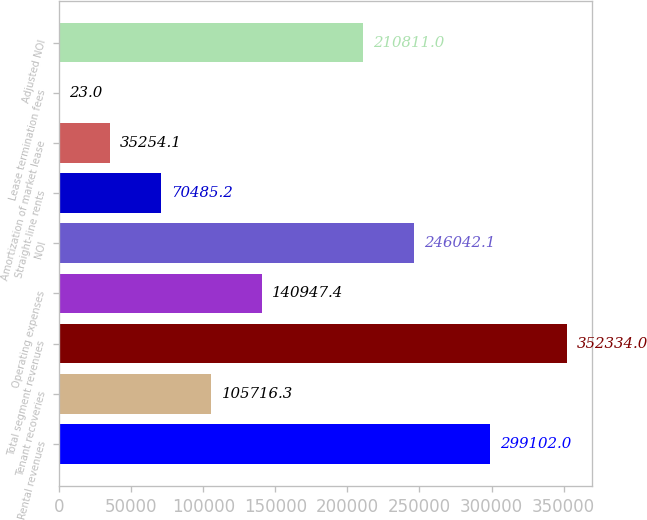Convert chart. <chart><loc_0><loc_0><loc_500><loc_500><bar_chart><fcel>Rental revenues<fcel>Tenant recoveries<fcel>Total segment revenues<fcel>Operating expenses<fcel>NOI<fcel>Straight-line rents<fcel>Amortization of market lease<fcel>Lease termination fees<fcel>Adjusted NOI<nl><fcel>299102<fcel>105716<fcel>352334<fcel>140947<fcel>246042<fcel>70485.2<fcel>35254.1<fcel>23<fcel>210811<nl></chart> 